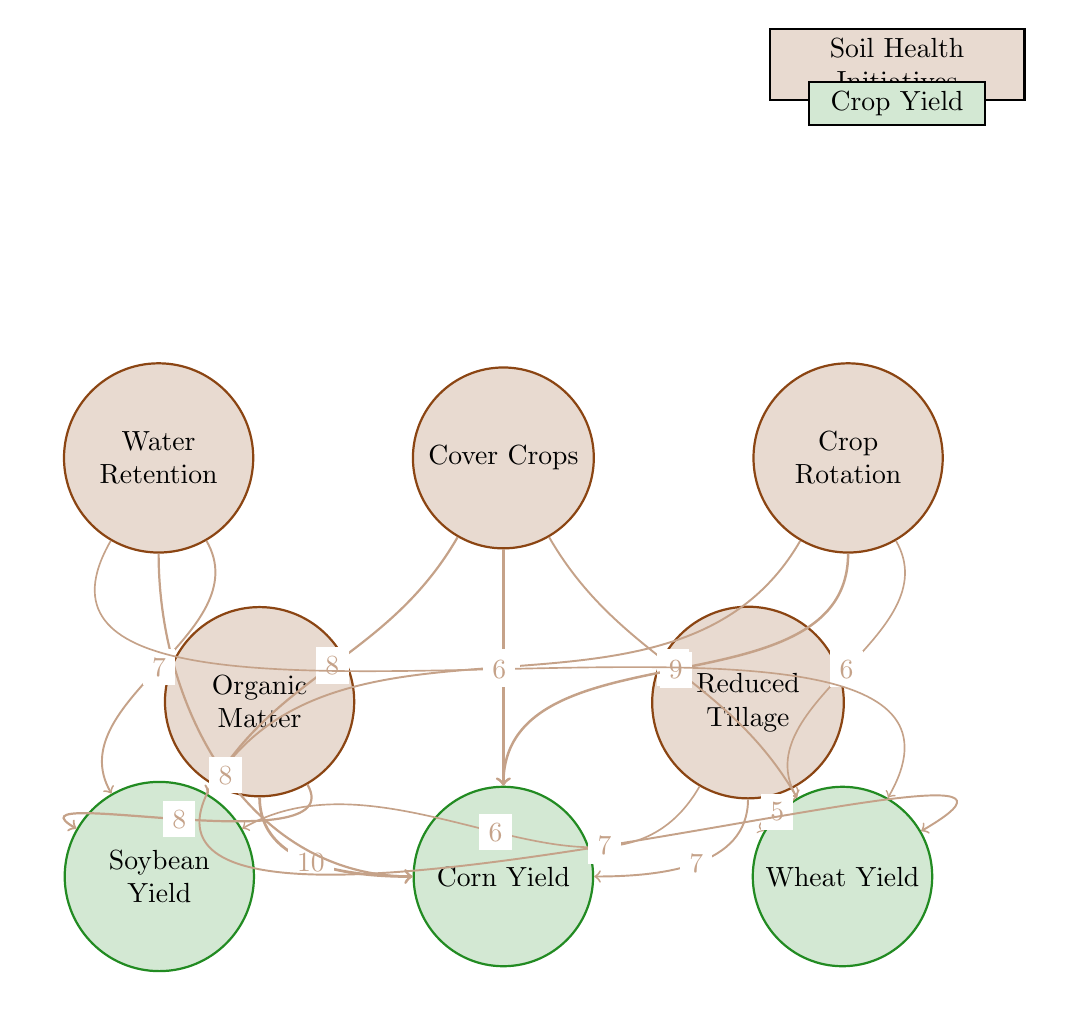What is the value associated with Cover Crops and Soybean Yield? In the diagram, the link between Cover Crops and Soybean Yield has a value of 8, which indicates the level of impact Cover Crops have on the yield of Soybeans.
Answer: 8 Which Soil Health Initiative has the highest value linking to Corn Yield? After analyzing the connections to Corn Yield, the link from Organic Matter has the highest value of 10, indicating it has the most significant impact on Corn Yield compared to other initiatives.
Answer: 10 How many links are there in total in this diagram? By counting the individual connections between Soil Health Initiatives and Crop Yields, there are 15 links total.
Answer: 15 What is the relationship between Reduced Tillage and Wheat Yield? The diagram shows a direct link from Reduced Tillage to Wheat Yield with a value of 5, indicating how this initiative affects the yield.
Answer: 5 Which Soil Health Initiative has a lower impact on Soybean Yield: Crop Rotation or Water Retention? Comparing the values, Crop Rotation has a value of 7, while Water Retention has a value of 7 as well, meaning they have the same impact on Soybean Yield.
Answer: Same Which crop has the highest combined yield values from all Soil Health Initiatives? By summing the values associated with Corn Yield across all initiatives (10 + 9 + 7 + 10 + 8), Corn Yield has the highest total of 44.
Answer: 44 List the Soil Health Initiative that contributes to Wheat Yield the least? Analyzing the values linked to Wheat Yield, Reduced Tillage contributes the least with a value of 5, demonstrating its lower impact compared to others.
Answer: Reduced Tillage What is the total value for Crop Rotation and Water Retention influencing Corn Yield? Evaluating the values, Crop Rotation contributes 9 and Water Retention contributes 8 to Corn Yield. The total is 9 + 8 = 17.
Answer: 17 